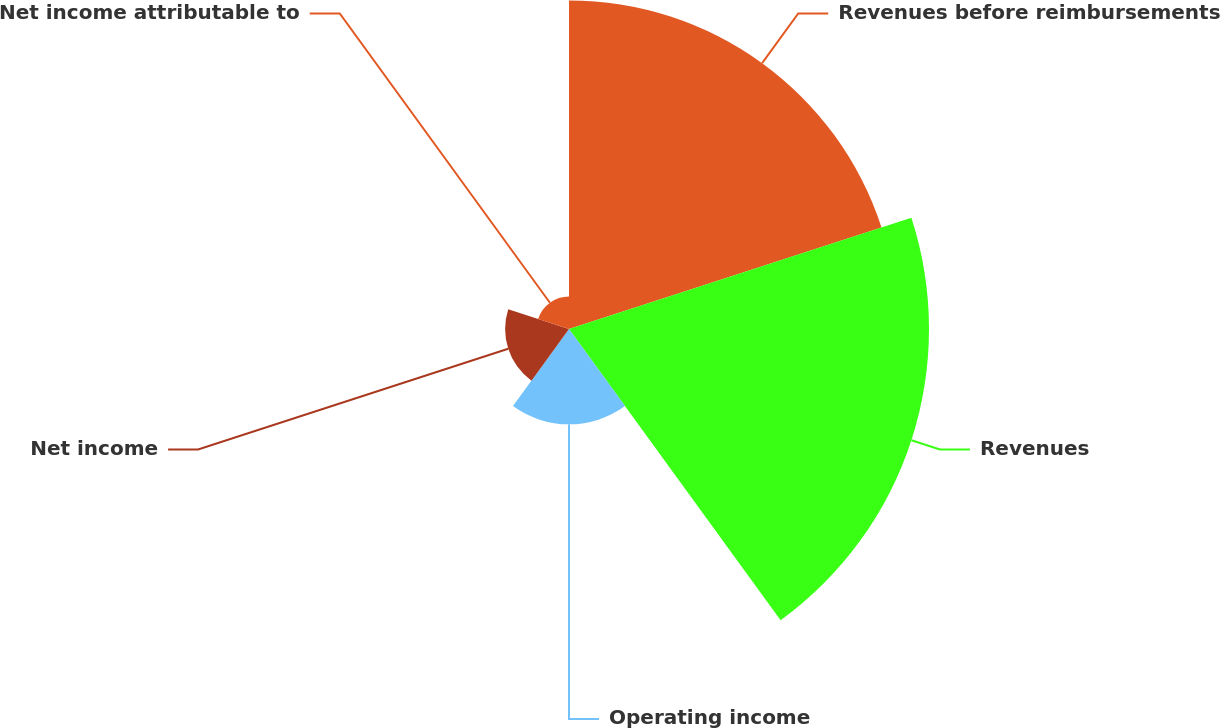<chart> <loc_0><loc_0><loc_500><loc_500><pie_chart><fcel>Revenues before reimbursements<fcel>Revenues<fcel>Operating income<fcel>Net income<fcel>Net income attributable to<nl><fcel>37.33%<fcel>40.9%<fcel>10.83%<fcel>7.26%<fcel>3.69%<nl></chart> 